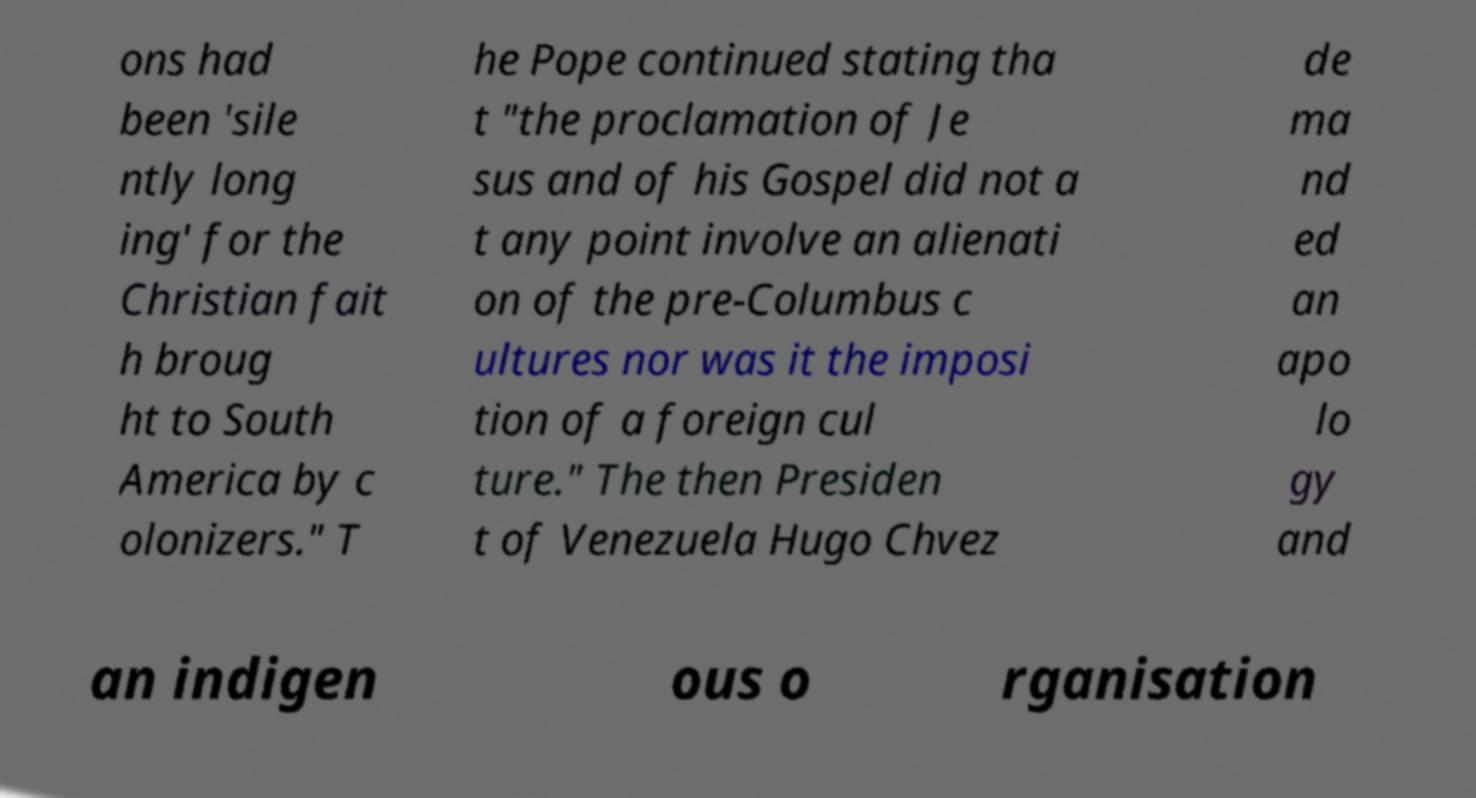Could you extract and type out the text from this image? ons had been 'sile ntly long ing' for the Christian fait h broug ht to South America by c olonizers." T he Pope continued stating tha t "the proclamation of Je sus and of his Gospel did not a t any point involve an alienati on of the pre-Columbus c ultures nor was it the imposi tion of a foreign cul ture." The then Presiden t of Venezuela Hugo Chvez de ma nd ed an apo lo gy and an indigen ous o rganisation 